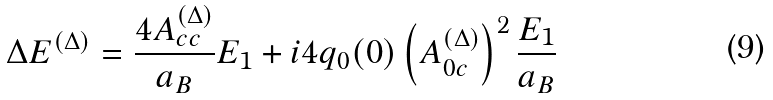Convert formula to latex. <formula><loc_0><loc_0><loc_500><loc_500>\Delta E ^ { ( \Delta ) } = \frac { 4 A ^ { ( \Delta ) } _ { c c } } { a _ { B } } E _ { 1 } + i 4 q _ { 0 } ( 0 ) \left ( A ^ { ( \Delta ) } _ { 0 c } \right ) ^ { 2 } \frac { E _ { 1 } } { a _ { B } }</formula> 